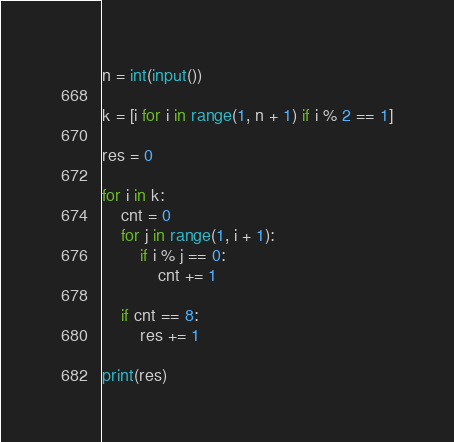<code> <loc_0><loc_0><loc_500><loc_500><_Python_>n = int(input())

k = [i for i in range(1, n + 1) if i % 2 == 1]

res = 0

for i in k:
    cnt = 0
    for j in range(1, i + 1):
        if i % j == 0:
            cnt += 1
            
    if cnt == 8:
        res += 1

print(res)</code> 